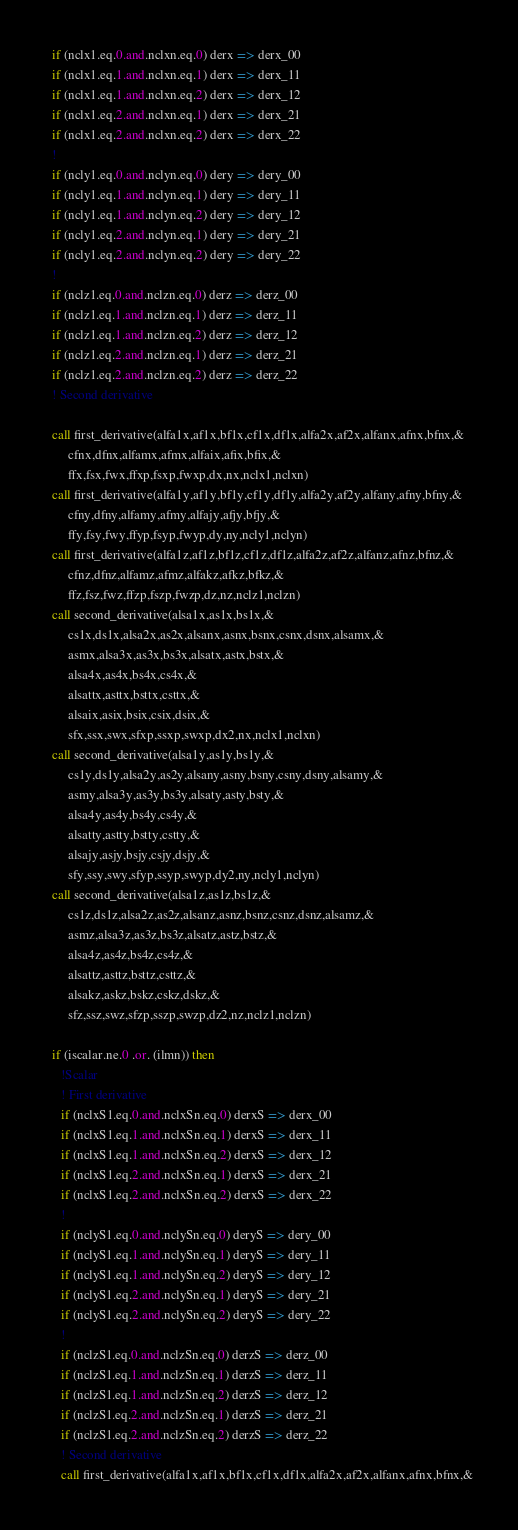<code> <loc_0><loc_0><loc_500><loc_500><_FORTRAN_>  if (nclx1.eq.0.and.nclxn.eq.0) derx => derx_00
  if (nclx1.eq.1.and.nclxn.eq.1) derx => derx_11
  if (nclx1.eq.1.and.nclxn.eq.2) derx => derx_12
  if (nclx1.eq.2.and.nclxn.eq.1) derx => derx_21
  if (nclx1.eq.2.and.nclxn.eq.2) derx => derx_22
  !
  if (ncly1.eq.0.and.nclyn.eq.0) dery => dery_00
  if (ncly1.eq.1.and.nclyn.eq.1) dery => dery_11
  if (ncly1.eq.1.and.nclyn.eq.2) dery => dery_12
  if (ncly1.eq.2.and.nclyn.eq.1) dery => dery_21
  if (ncly1.eq.2.and.nclyn.eq.2) dery => dery_22
  !
  if (nclz1.eq.0.and.nclzn.eq.0) derz => derz_00
  if (nclz1.eq.1.and.nclzn.eq.1) derz => derz_11
  if (nclz1.eq.1.and.nclzn.eq.2) derz => derz_12
  if (nclz1.eq.2.and.nclzn.eq.1) derz => derz_21
  if (nclz1.eq.2.and.nclzn.eq.2) derz => derz_22
  ! Second derivative

  call first_derivative(alfa1x,af1x,bf1x,cf1x,df1x,alfa2x,af2x,alfanx,afnx,bfnx,&
       cfnx,dfnx,alfamx,afmx,alfaix,afix,bfix,&
       ffx,fsx,fwx,ffxp,fsxp,fwxp,dx,nx,nclx1,nclxn)
  call first_derivative(alfa1y,af1y,bf1y,cf1y,df1y,alfa2y,af2y,alfany,afny,bfny,&
       cfny,dfny,alfamy,afmy,alfajy,afjy,bfjy,&
       ffy,fsy,fwy,ffyp,fsyp,fwyp,dy,ny,ncly1,nclyn)
  call first_derivative(alfa1z,af1z,bf1z,cf1z,df1z,alfa2z,af2z,alfanz,afnz,bfnz,&
       cfnz,dfnz,alfamz,afmz,alfakz,afkz,bfkz,&
       ffz,fsz,fwz,ffzp,fszp,fwzp,dz,nz,nclz1,nclzn)
  call second_derivative(alsa1x,as1x,bs1x,&
       cs1x,ds1x,alsa2x,as2x,alsanx,asnx,bsnx,csnx,dsnx,alsamx,&
       asmx,alsa3x,as3x,bs3x,alsatx,astx,bstx,&
       alsa4x,as4x,bs4x,cs4x,&
       alsattx,asttx,bsttx,csttx,&
       alsaix,asix,bsix,csix,dsix,&
       sfx,ssx,swx,sfxp,ssxp,swxp,dx2,nx,nclx1,nclxn)
  call second_derivative(alsa1y,as1y,bs1y,&
       cs1y,ds1y,alsa2y,as2y,alsany,asny,bsny,csny,dsny,alsamy,&
       asmy,alsa3y,as3y,bs3y,alsaty,asty,bsty,&
       alsa4y,as4y,bs4y,cs4y,&
       alsatty,astty,bstty,cstty,&
       alsajy,asjy,bsjy,csjy,dsjy,&
       sfy,ssy,swy,sfyp,ssyp,swyp,dy2,ny,ncly1,nclyn)
  call second_derivative(alsa1z,as1z,bs1z,&
       cs1z,ds1z,alsa2z,as2z,alsanz,asnz,bsnz,csnz,dsnz,alsamz,&
       asmz,alsa3z,as3z,bs3z,alsatz,astz,bstz,&
       alsa4z,as4z,bs4z,cs4z,&
       alsattz,asttz,bsttz,csttz,&
       alsakz,askz,bskz,cskz,dskz,&
       sfz,ssz,swz,sfzp,sszp,swzp,dz2,nz,nclz1,nclzn)

  if (iscalar.ne.0 .or. (ilmn)) then
     !Scalar
     ! First derivative
     if (nclxS1.eq.0.and.nclxSn.eq.0) derxS => derx_00
     if (nclxS1.eq.1.and.nclxSn.eq.1) derxS => derx_11
     if (nclxS1.eq.1.and.nclxSn.eq.2) derxS => derx_12
     if (nclxS1.eq.2.and.nclxSn.eq.1) derxS => derx_21
     if (nclxS1.eq.2.and.nclxSn.eq.2) derxS => derx_22
     !
     if (nclyS1.eq.0.and.nclySn.eq.0) deryS => dery_00
     if (nclyS1.eq.1.and.nclySn.eq.1) deryS => dery_11
     if (nclyS1.eq.1.and.nclySn.eq.2) deryS => dery_12
     if (nclyS1.eq.2.and.nclySn.eq.1) deryS => dery_21
     if (nclyS1.eq.2.and.nclySn.eq.2) deryS => dery_22
     !
     if (nclzS1.eq.0.and.nclzSn.eq.0) derzS => derz_00
     if (nclzS1.eq.1.and.nclzSn.eq.1) derzS => derz_11
     if (nclzS1.eq.1.and.nclzSn.eq.2) derzS => derz_12
     if (nclzS1.eq.2.and.nclzSn.eq.1) derzS => derz_21
     if (nclzS1.eq.2.and.nclzSn.eq.2) derzS => derz_22
     ! Second derivative
     call first_derivative(alfa1x,af1x,bf1x,cf1x,df1x,alfa2x,af2x,alfanx,afnx,bfnx,&</code> 